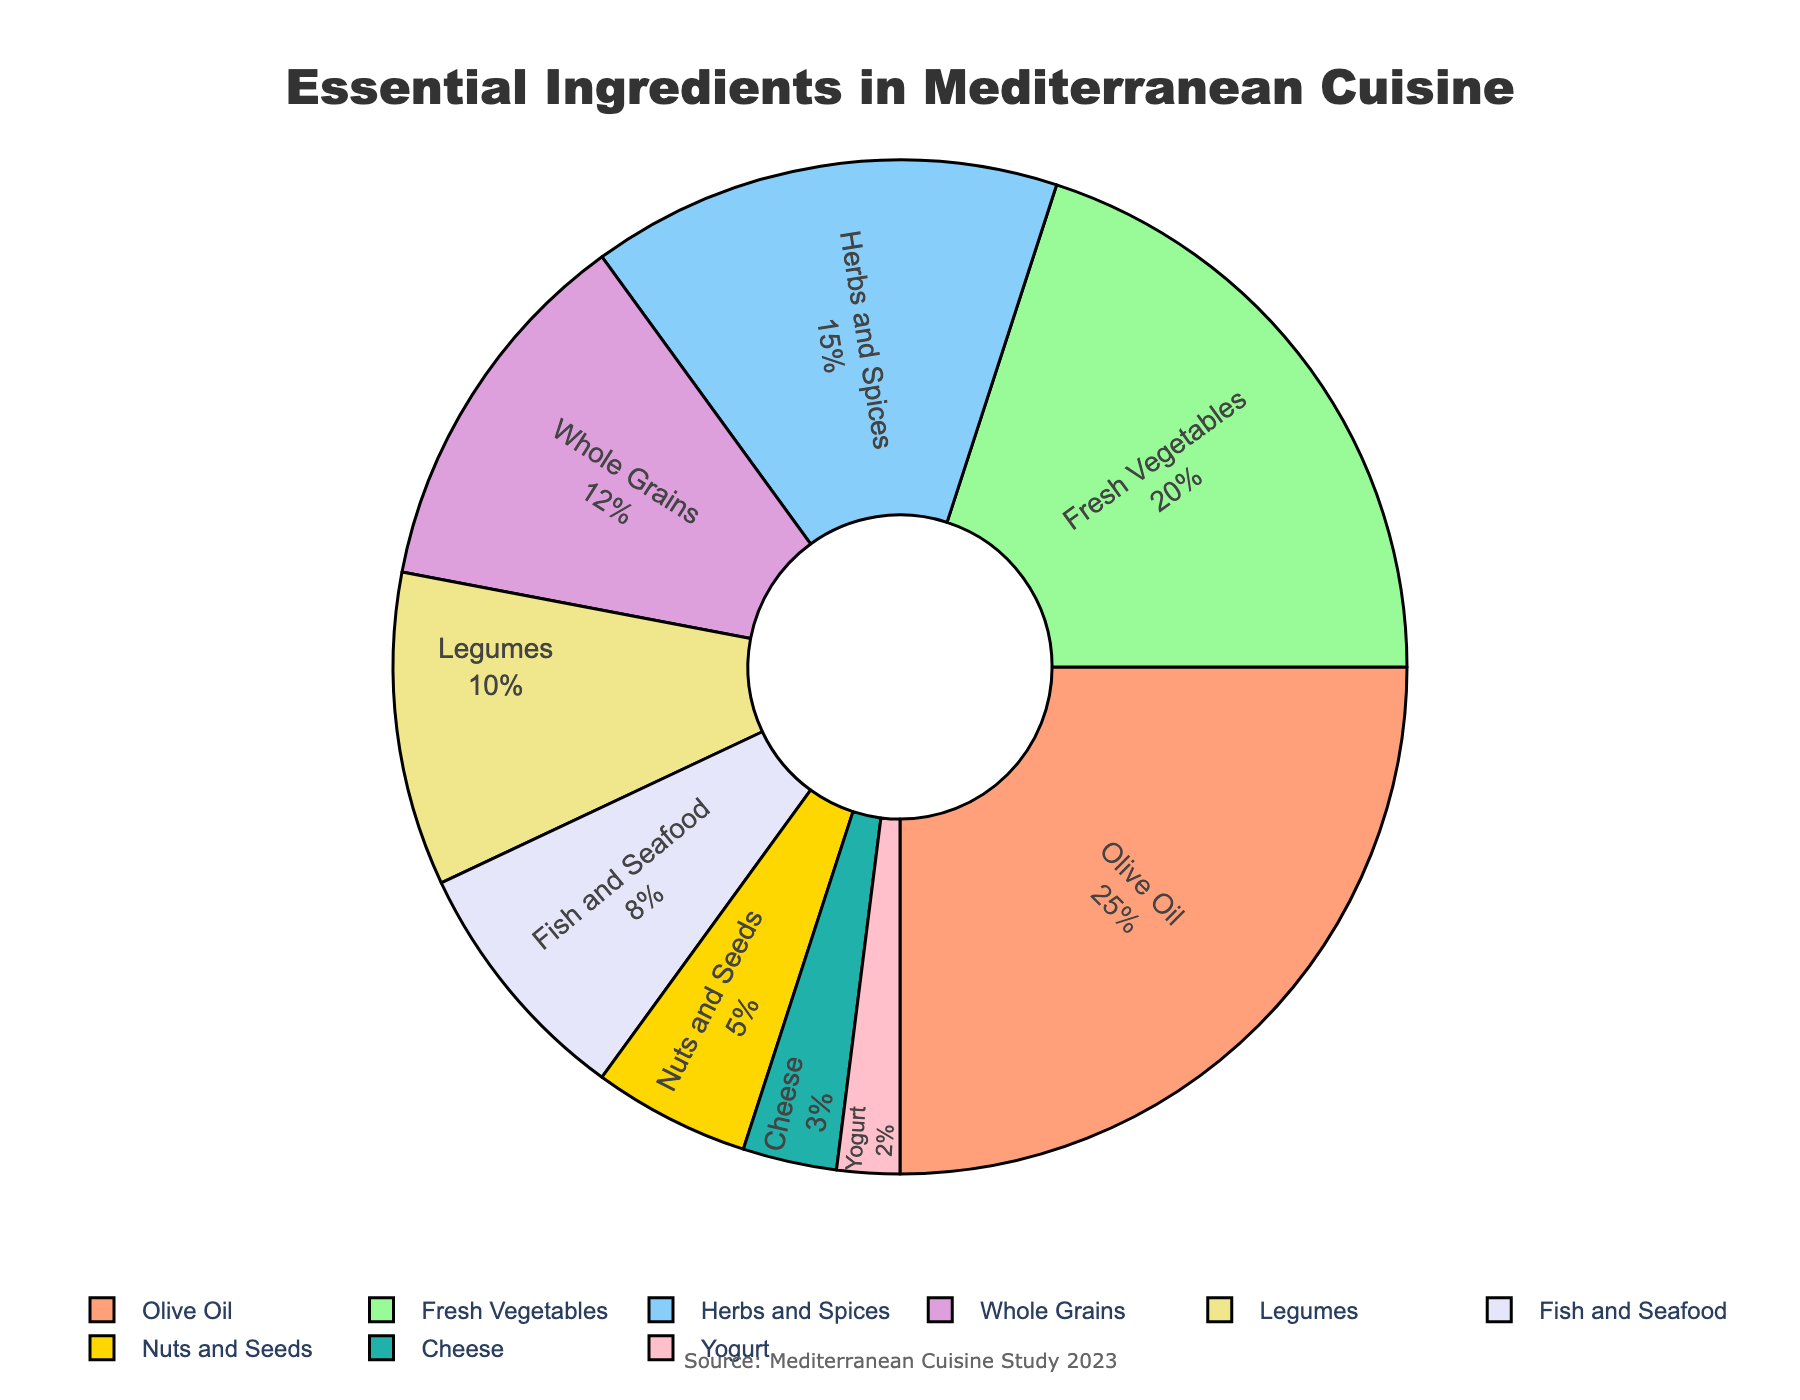What's the largest category of essential ingredients in Mediterranean cooking? Identify the segment with the highest percentage. The pie chart shows Olive Oil with 25% as the largest category.
Answer: Olive Oil Which category has a lower percentage: Fish and Seafood or Nuts and Seeds? Compare the percentages of Fish and Seafood and Nuts and Seeds. Fish and Seafood is 8%, and Nuts and Seeds is 5%, so Nuts and Seeds is lower.
Answer: Nuts and Seeds What is the combined percentage of Legumes, Fish and Seafood, and Cheese? Sum the percentages of Legumes (10%), Fish and Seafood (8%), and Cheese (3%). The combined total is 10% + 8% + 3% = 21%.
Answer: 21% How does the percentage of Whole Grains compare to Herbs and Spices? Compare the percentages of Whole Grains (12%) and Herbs and Spices (15%). Herbs and Spices have a higher percentage.
Answer: Herbs and Spices is higher Which category is represented by the green color on the pie chart? Identify the category associated with the green color segment. The Fresh Vegetables segment is colored green.
Answer: Fresh Vegetables Is the percentage of Fresh Vegetables greater than twice the percentage of Cheese? Compare if 20% (Fresh Vegetables) is greater than twice the percentage of 3% (Cheese). Twice the Cheese percentage is 6%, and 20% is greater than 6%.
Answer: Yes Calculate the average percentage of Herbs and Spices, Whole Grains, and Legumes. Find the average by summing the percentages (15% + 12% + 10% = 37%) and dividing by the number of categories (3). This gives an average of 37% / 3 ≈ 12.33%.
Answer: ≈ 12.33% Which category has the smallest percentage, and what is it? Identify the smallest percentage segment on the chart, which is Yogurt at 2%.
Answer: Yogurt with 2% How much more percentage does Olive Oil have compared to Cheese? Subtract Cheese percentage (3%) from Olive Oil percentage (25%). The difference is 25% - 3% = 22%.
Answer: 22% Which categories combined make up more than 50% of the total? Sum the highest percentages until the total exceeds 50%. Olive Oil (25%) + Fresh Vegetables (20%) = 45%, adding Herbs and Spices (15%) makes the total 60%, which exceeds 50%.
Answer: Olive Oil, Fresh Vegetables, Herbs and Spices 